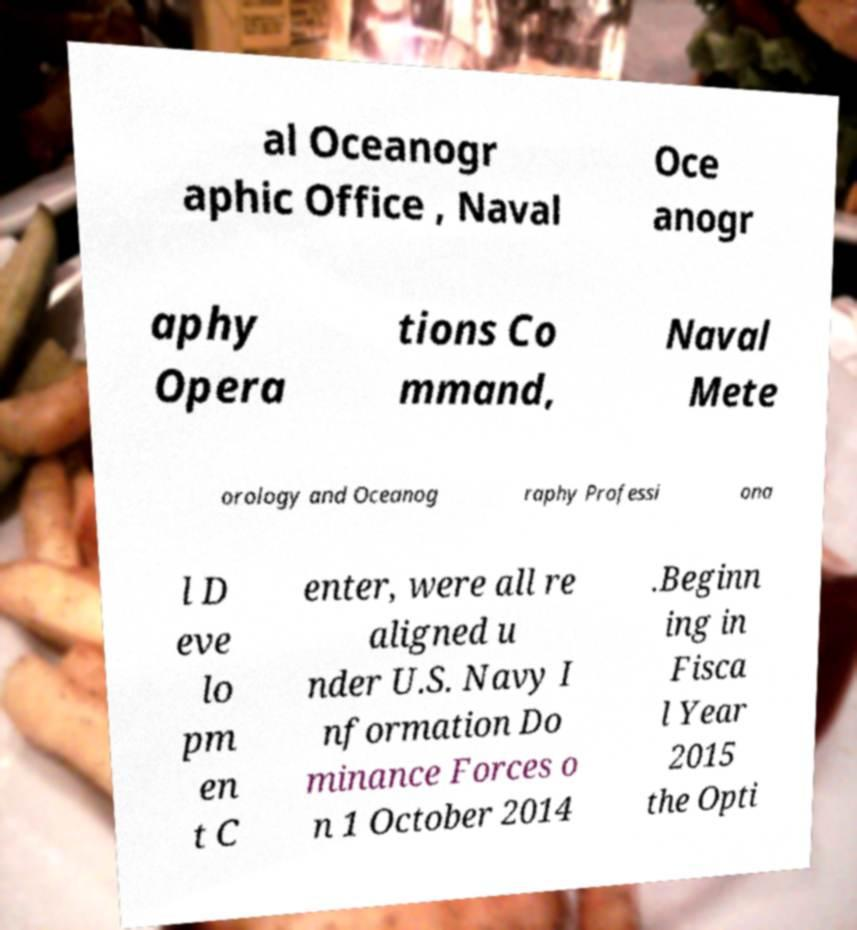Could you assist in decoding the text presented in this image and type it out clearly? al Oceanogr aphic Office , Naval Oce anogr aphy Opera tions Co mmand, Naval Mete orology and Oceanog raphy Professi ona l D eve lo pm en t C enter, were all re aligned u nder U.S. Navy I nformation Do minance Forces o n 1 October 2014 .Beginn ing in Fisca l Year 2015 the Opti 